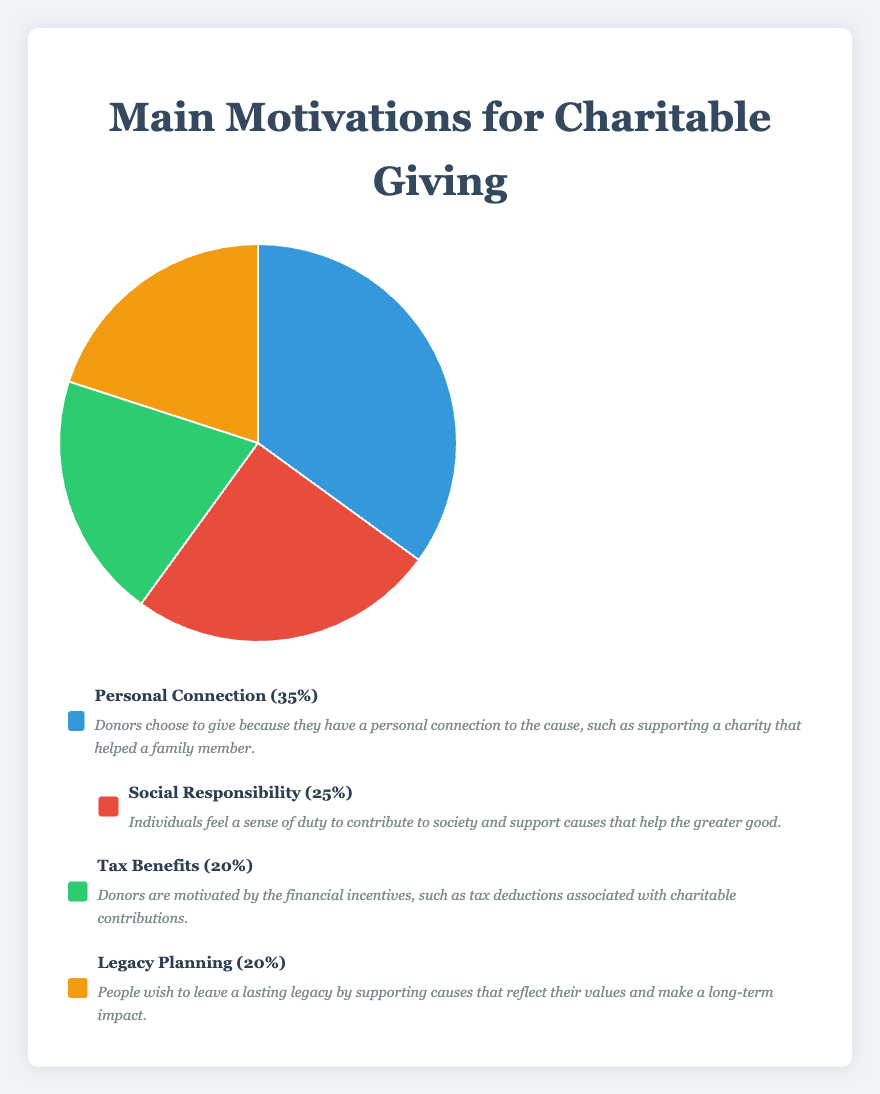What is the most common motivation for charitable giving? By looking at the figure, the "Personal Connection" section of the pie chart occupies the largest portion.
Answer: Personal Connection Which motivations have the same percentage of donors? The figure shows that "Tax Benefits" and "Legacy Planning" each occupy 20% of the pie chart.
Answer: Tax Benefits and Legacy Planning What is the total percentage of donors motivated by either "Tax Benefits" or "Legacy Planning"? Add the percentages for "Tax Benefits" (20%) and "Legacy Planning" (20%).
Answer: 40% How does the percentage of donors motivated by "Social Responsibility" compare to those motivated by "Personal Connection"? The pie chart shows that "Social Responsibility" accounts for 25% while "Personal Connection" accounts for 35%.
Answer: Social Responsibility is less than Personal Connection What is the average percentage of donors across all motivations? Sum the percentages (35 + 25 + 20 + 20) and divide by 4 motivations. The sum is 100, and the average is 100/4.
Answer: 25% What color on the chart represents the "Social Responsibility" motivation? The pie chart uses different colors for each section, and "Social Responsibility" is represented by the red section.
Answer: Red Which motivation occupies the smallest portion(s) of the pie chart, and what is the visual clue for this? "Tax Benefits" and "Legacy Planning" each occupy the smallest portions, 20% each, which are visually identical in size.
Answer: Tax Benefits and Legacy Planning What is the visual difference between the segments representing "Personal Connection" and "Social Responsibility"? The segment for "Personal Connection" is larger and blue, whereas "Social Responsibility" is smaller and red.
Answer: Blue segment is larger (Personal Connection), Red segment is smaller (Social Responsibility) 